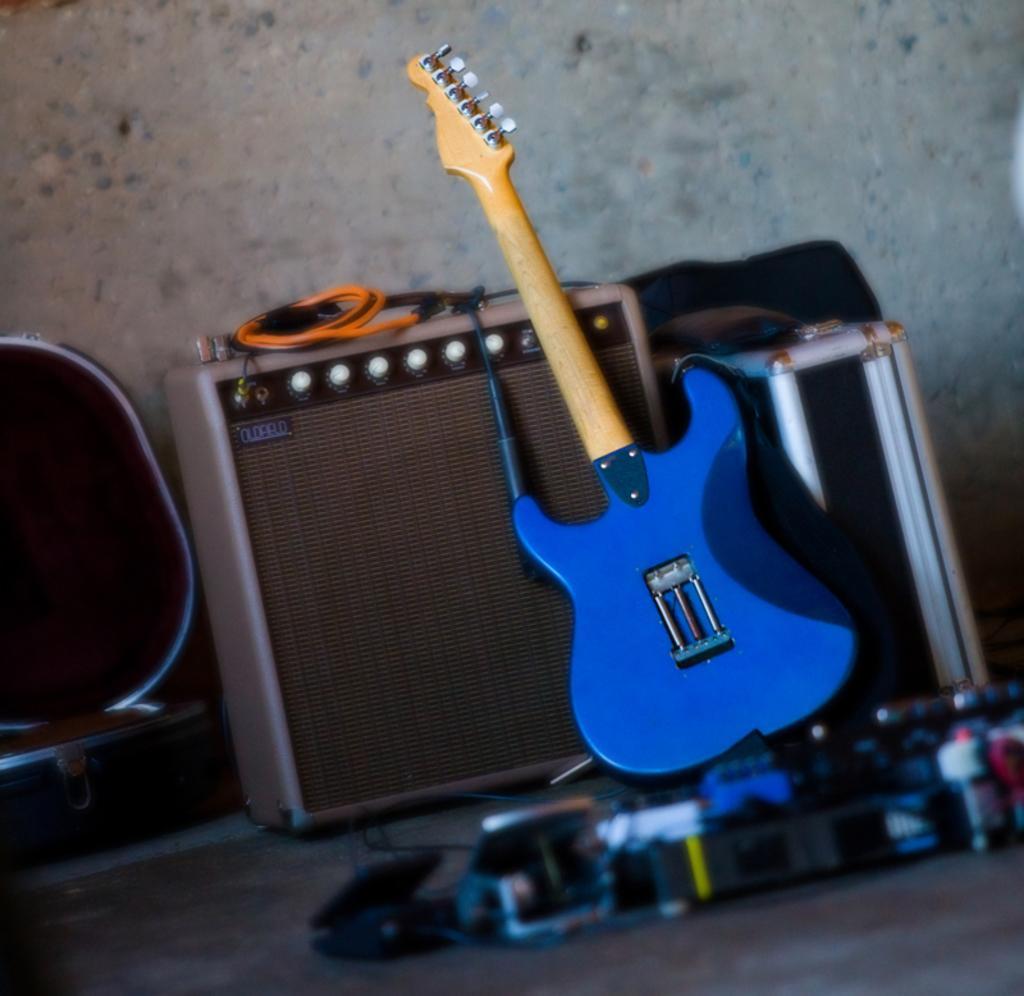In one or two sentences, can you explain what this image depicts? In this image we can see toys like guitar, speaker and an object. At the bottom there is a floor. In the background there is a wall. 